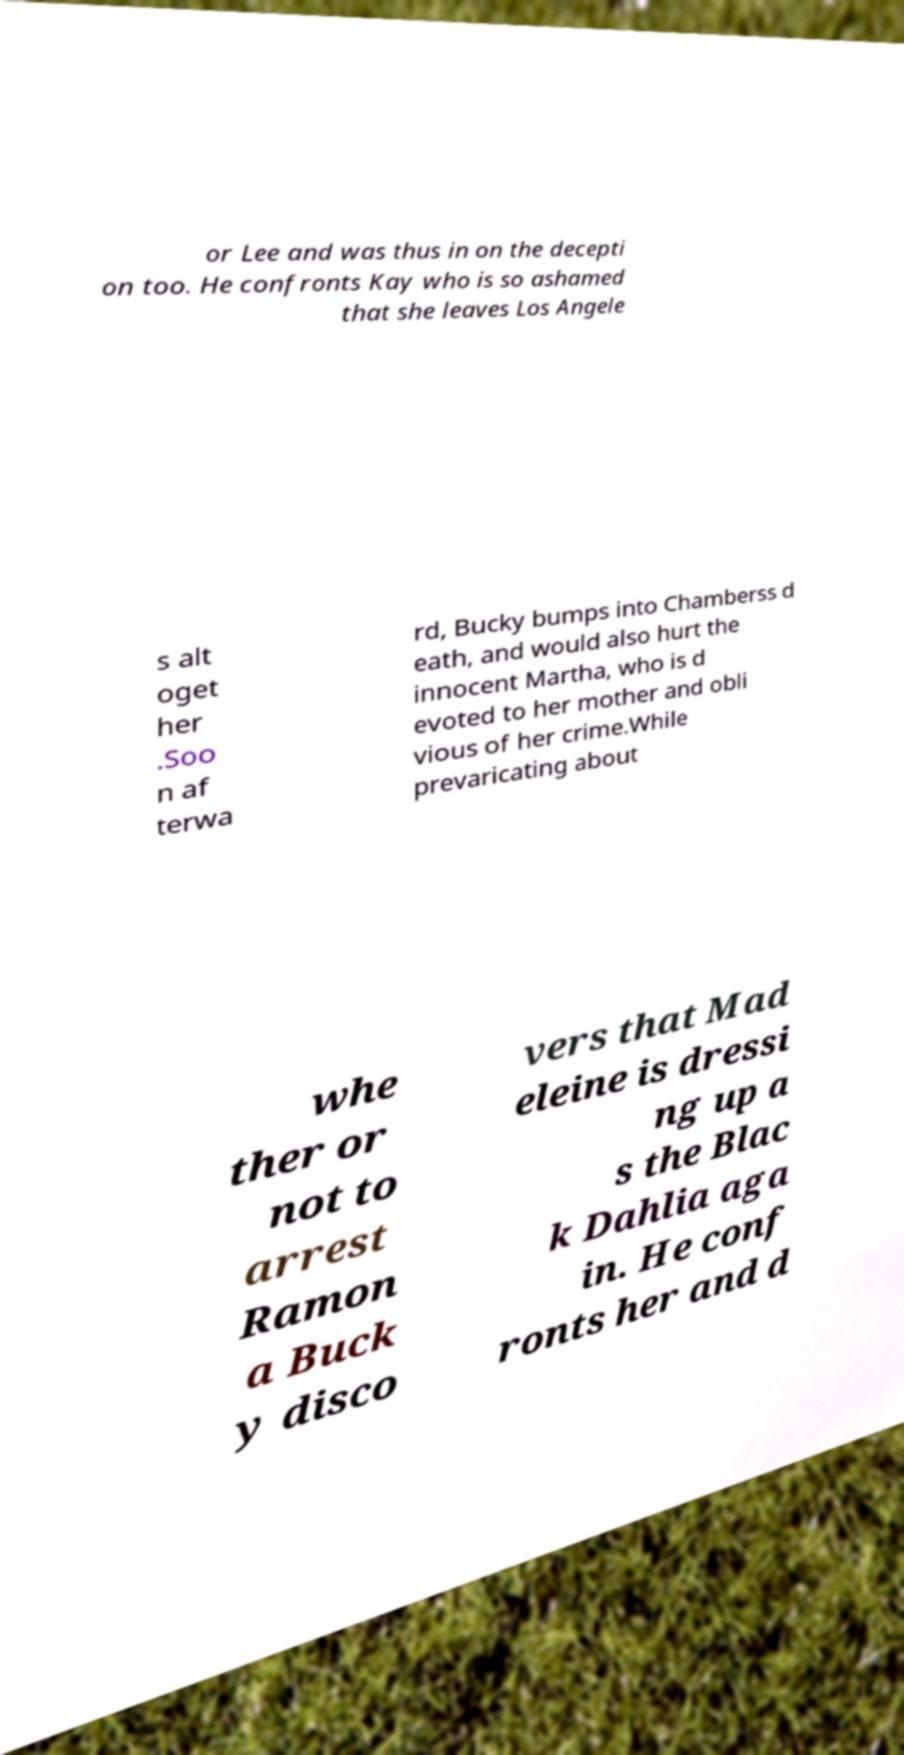Please read and relay the text visible in this image. What does it say? or Lee and was thus in on the decepti on too. He confronts Kay who is so ashamed that she leaves Los Angele s alt oget her .Soo n af terwa rd, Bucky bumps into Chamberss d eath, and would also hurt the innocent Martha, who is d evoted to her mother and obli vious of her crime.While prevaricating about whe ther or not to arrest Ramon a Buck y disco vers that Mad eleine is dressi ng up a s the Blac k Dahlia aga in. He conf ronts her and d 